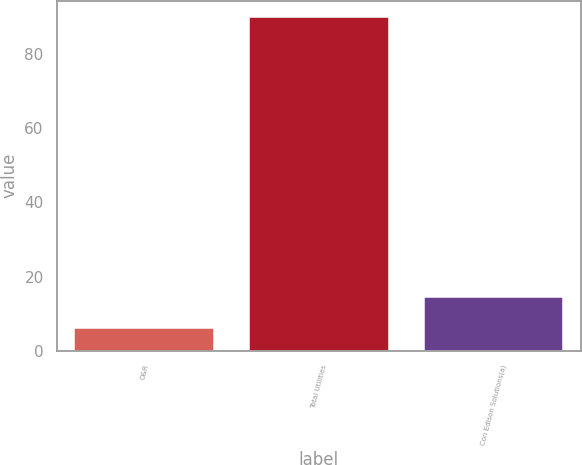<chart> <loc_0><loc_0><loc_500><loc_500><bar_chart><fcel>O&R<fcel>Total Utilities<fcel>Con Edison Solutions(a)<nl><fcel>6<fcel>90<fcel>14.4<nl></chart> 